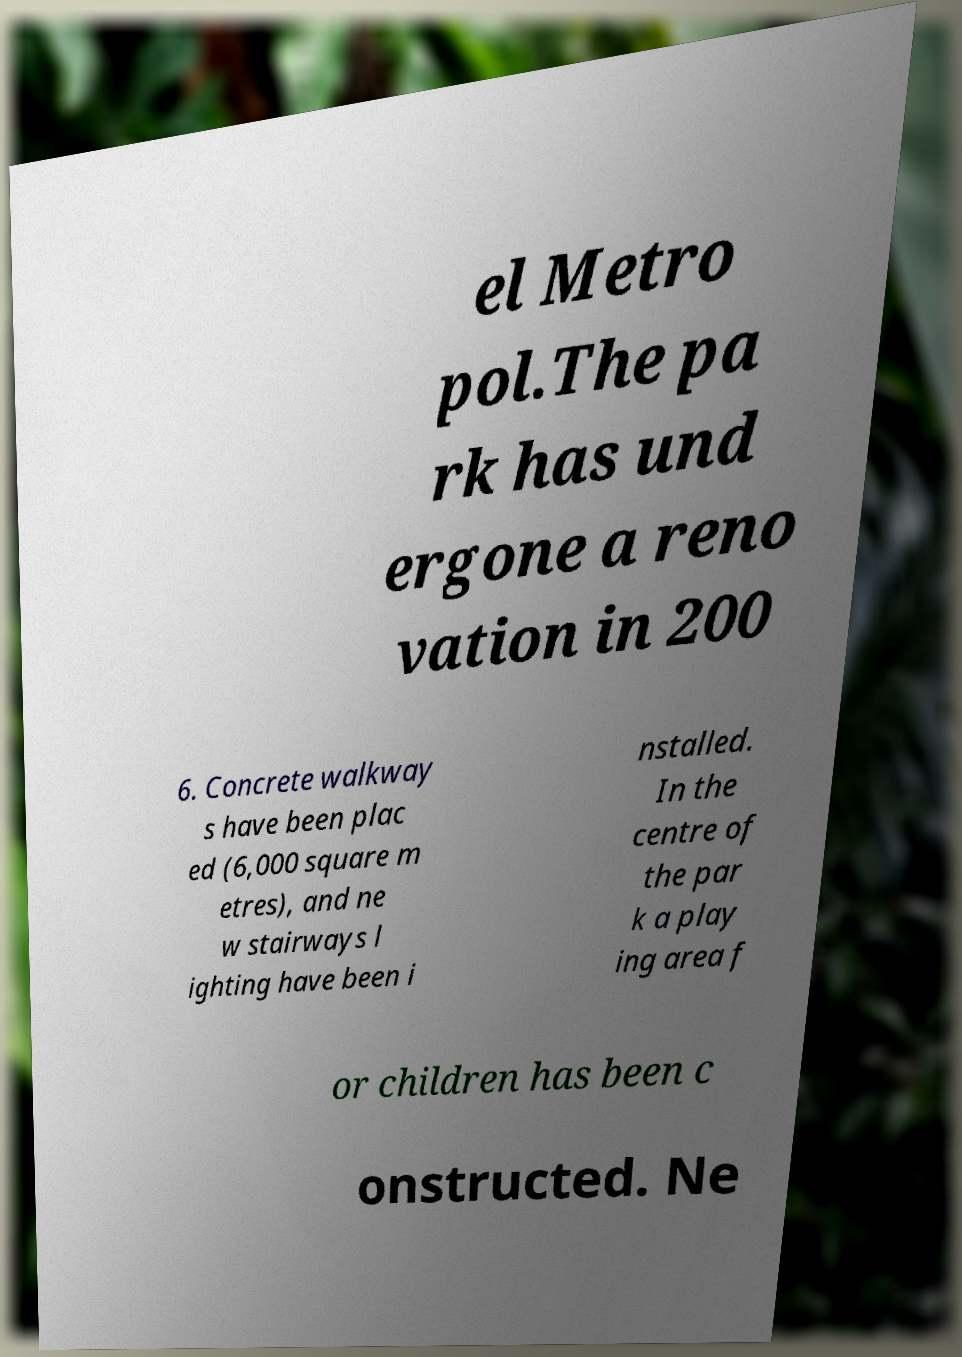For documentation purposes, I need the text within this image transcribed. Could you provide that? el Metro pol.The pa rk has und ergone a reno vation in 200 6. Concrete walkway s have been plac ed (6,000 square m etres), and ne w stairways l ighting have been i nstalled. In the centre of the par k a play ing area f or children has been c onstructed. Ne 